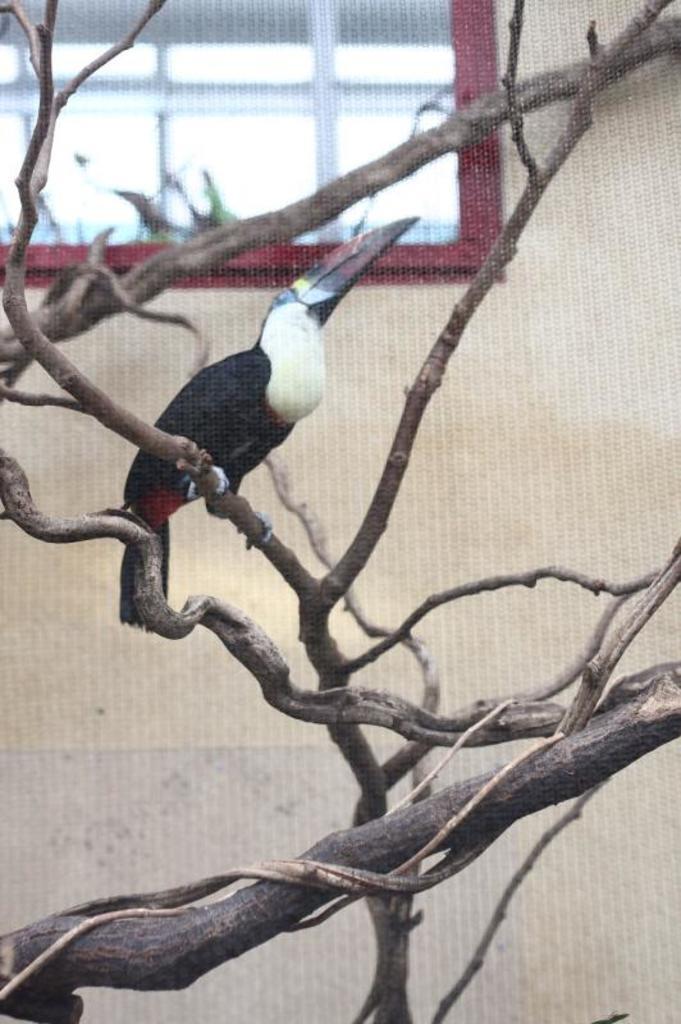Could you give a brief overview of what you see in this image? In this picture we can see a bird on a branch of a tree. In the background we can see a window and the wall. 